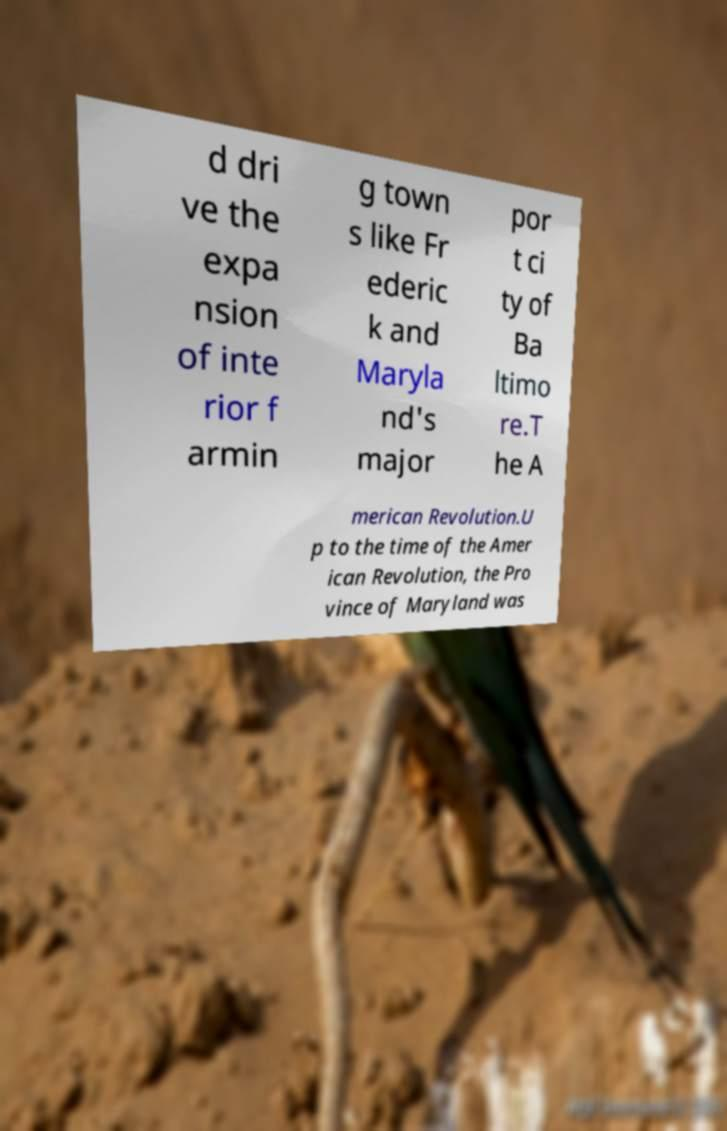Could you extract and type out the text from this image? d dri ve the expa nsion of inte rior f armin g town s like Fr ederic k and Maryla nd's major por t ci ty of Ba ltimo re.T he A merican Revolution.U p to the time of the Amer ican Revolution, the Pro vince of Maryland was 